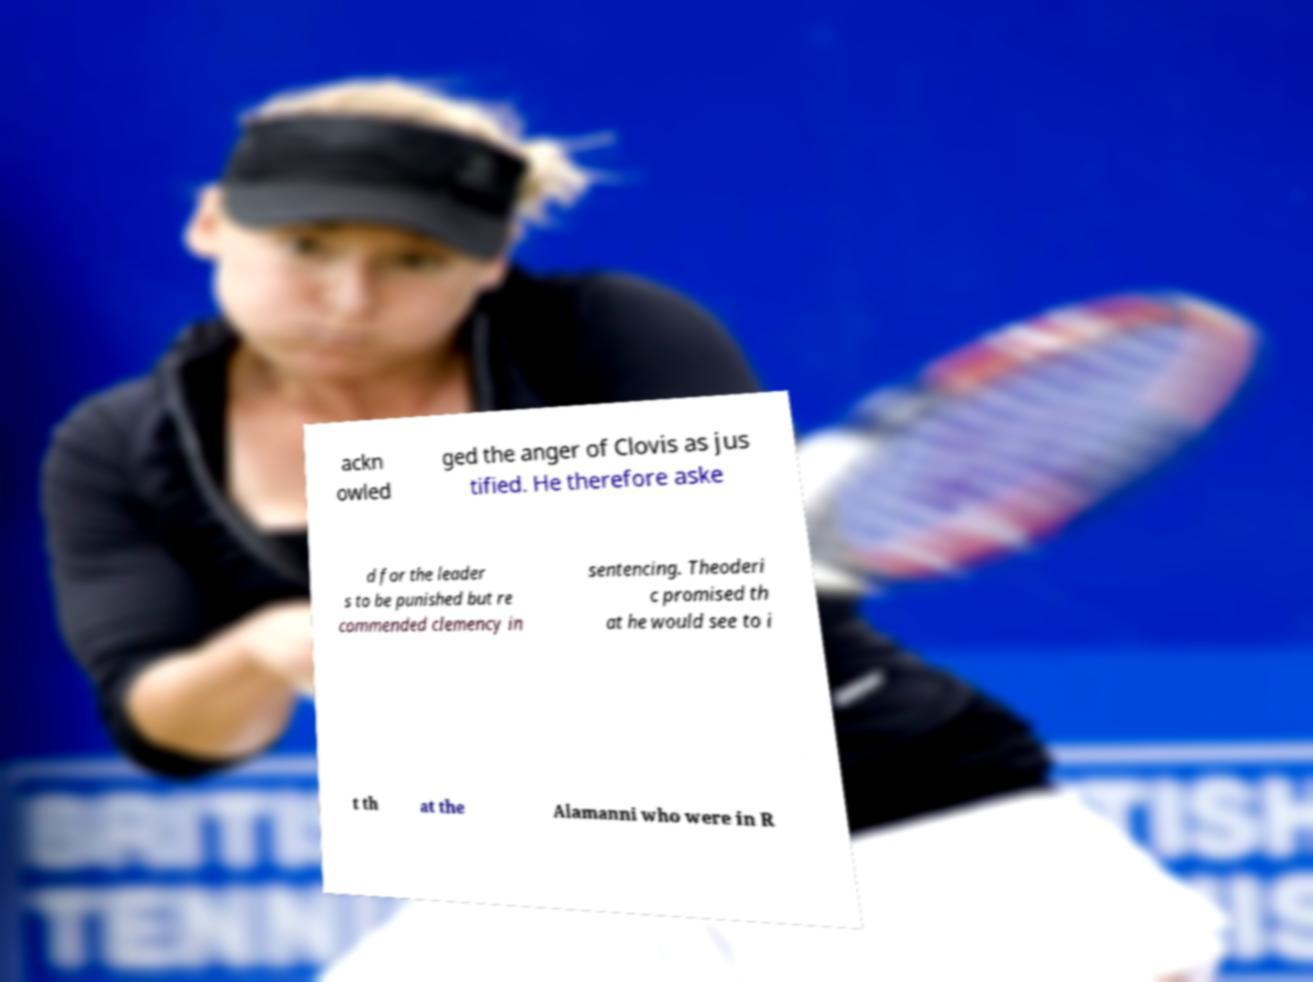Could you assist in decoding the text presented in this image and type it out clearly? ackn owled ged the anger of Clovis as jus tified. He therefore aske d for the leader s to be punished but re commended clemency in sentencing. Theoderi c promised th at he would see to i t th at the Alamanni who were in R 